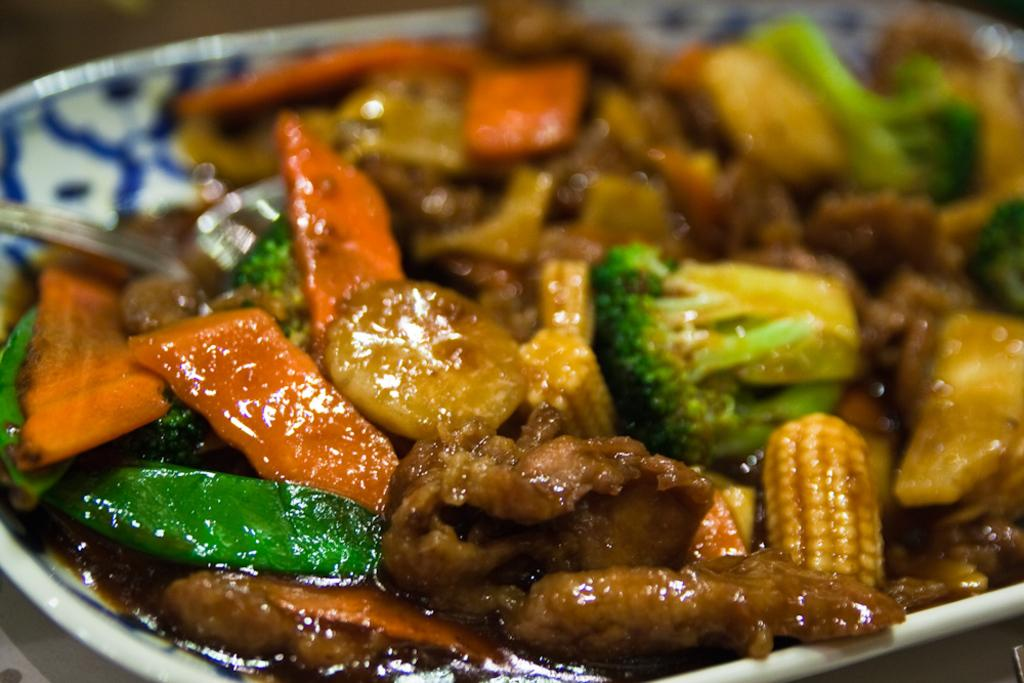What is the main subject of the image? There is a food item on a plate in the image. What type of cabbage can be seen growing in the image? There is no cabbage present in the image; it only features a food item on a plate. How many rings are visible on the food item in the image? There is no indication of rings on the food item in the image. 